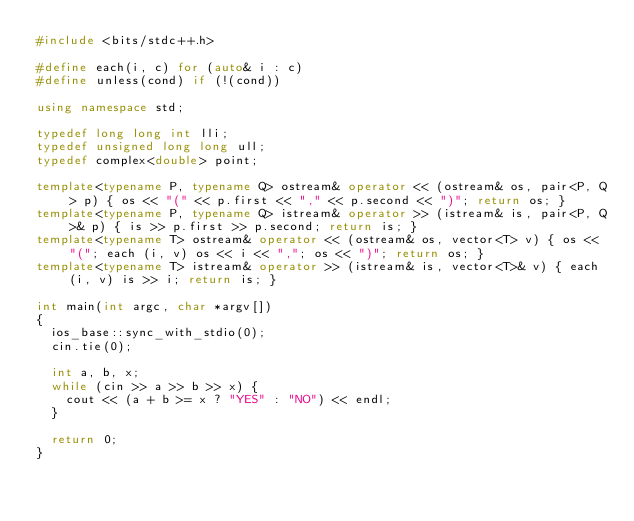<code> <loc_0><loc_0><loc_500><loc_500><_C++_>#include <bits/stdc++.h>

#define each(i, c) for (auto& i : c)
#define unless(cond) if (!(cond))

using namespace std;

typedef long long int lli;
typedef unsigned long long ull;
typedef complex<double> point;

template<typename P, typename Q> ostream& operator << (ostream& os, pair<P, Q> p) { os << "(" << p.first << "," << p.second << ")"; return os; }
template<typename P, typename Q> istream& operator >> (istream& is, pair<P, Q>& p) { is >> p.first >> p.second; return is; }
template<typename T> ostream& operator << (ostream& os, vector<T> v) { os << "("; each (i, v) os << i << ","; os << ")"; return os; }
template<typename T> istream& operator >> (istream& is, vector<T>& v) { each (i, v) is >> i; return is; }

int main(int argc, char *argv[])
{
  ios_base::sync_with_stdio(0);
  cin.tie(0);

  int a, b, x;
  while (cin >> a >> b >> x) {
    cout << (a + b >= x ? "YES" : "NO") << endl;
  }
  
  return 0;
}
</code> 